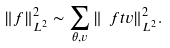<formula> <loc_0><loc_0><loc_500><loc_500>\| f \| _ { L ^ { 2 } } ^ { 2 } \sim \sum _ { \theta , v } \| \ f t v \| _ { L ^ { 2 } } ^ { 2 } .</formula> 